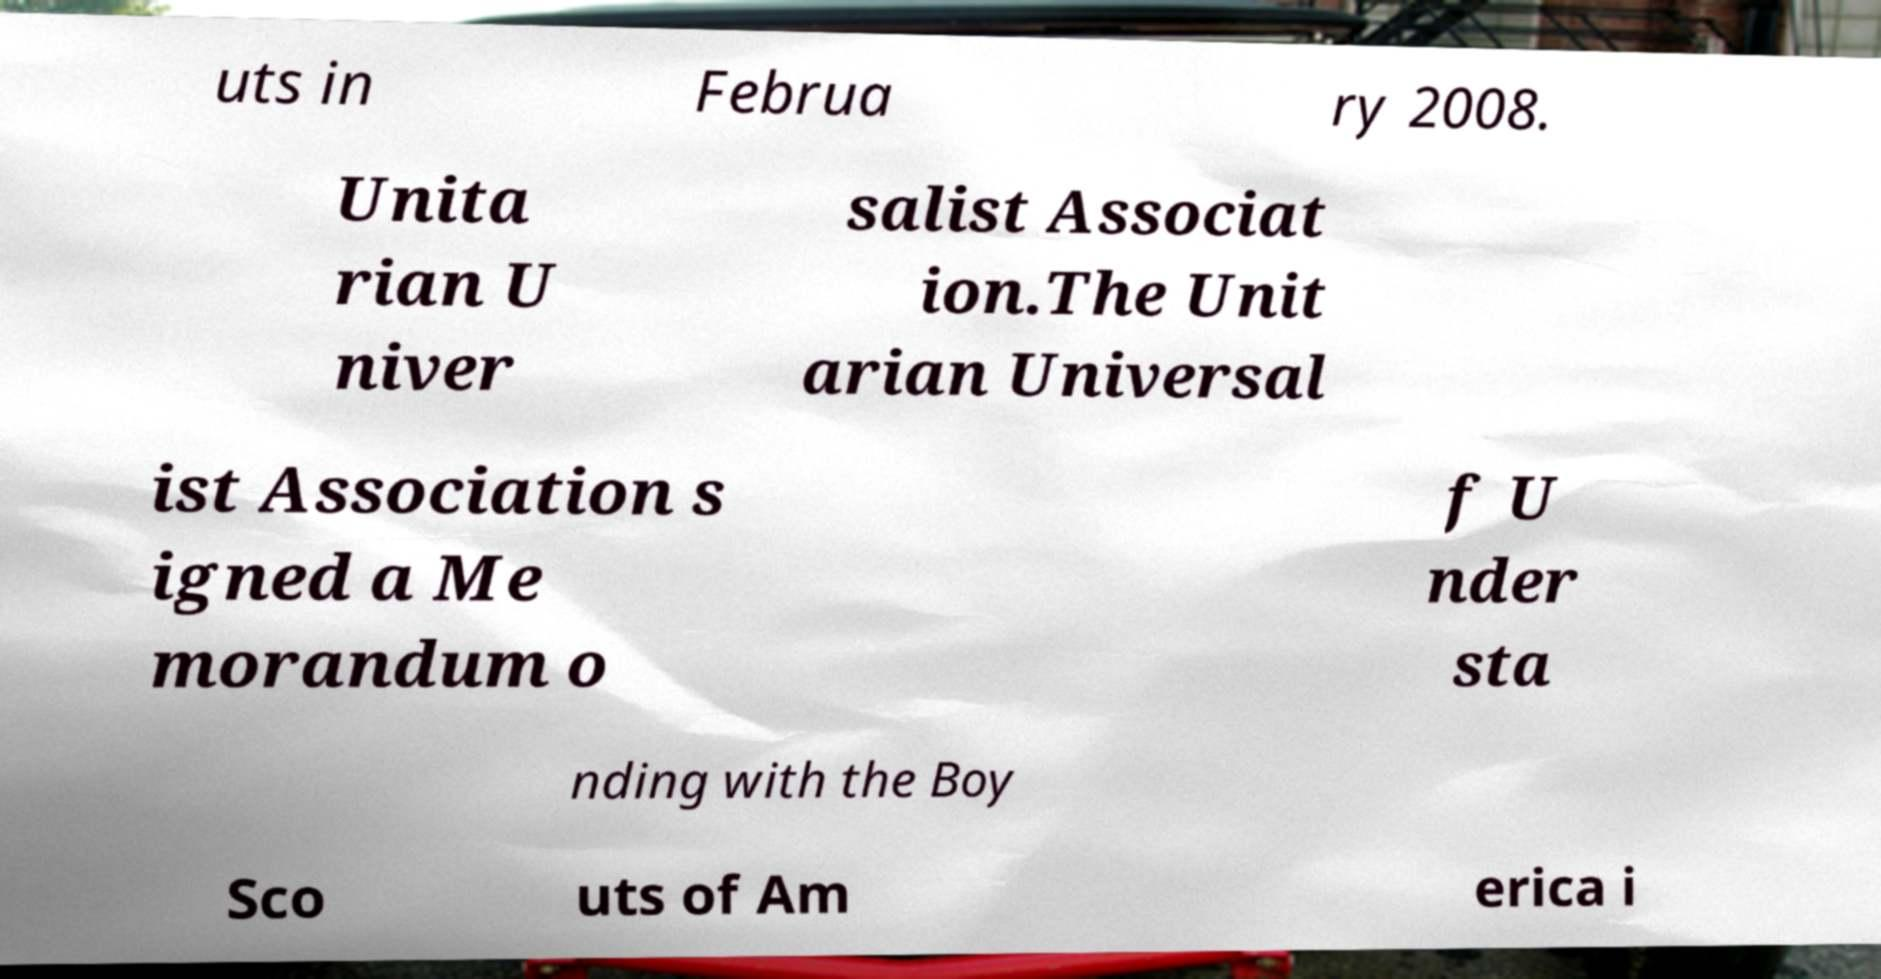What messages or text are displayed in this image? I need them in a readable, typed format. uts in Februa ry 2008. Unita rian U niver salist Associat ion.The Unit arian Universal ist Association s igned a Me morandum o f U nder sta nding with the Boy Sco uts of Am erica i 